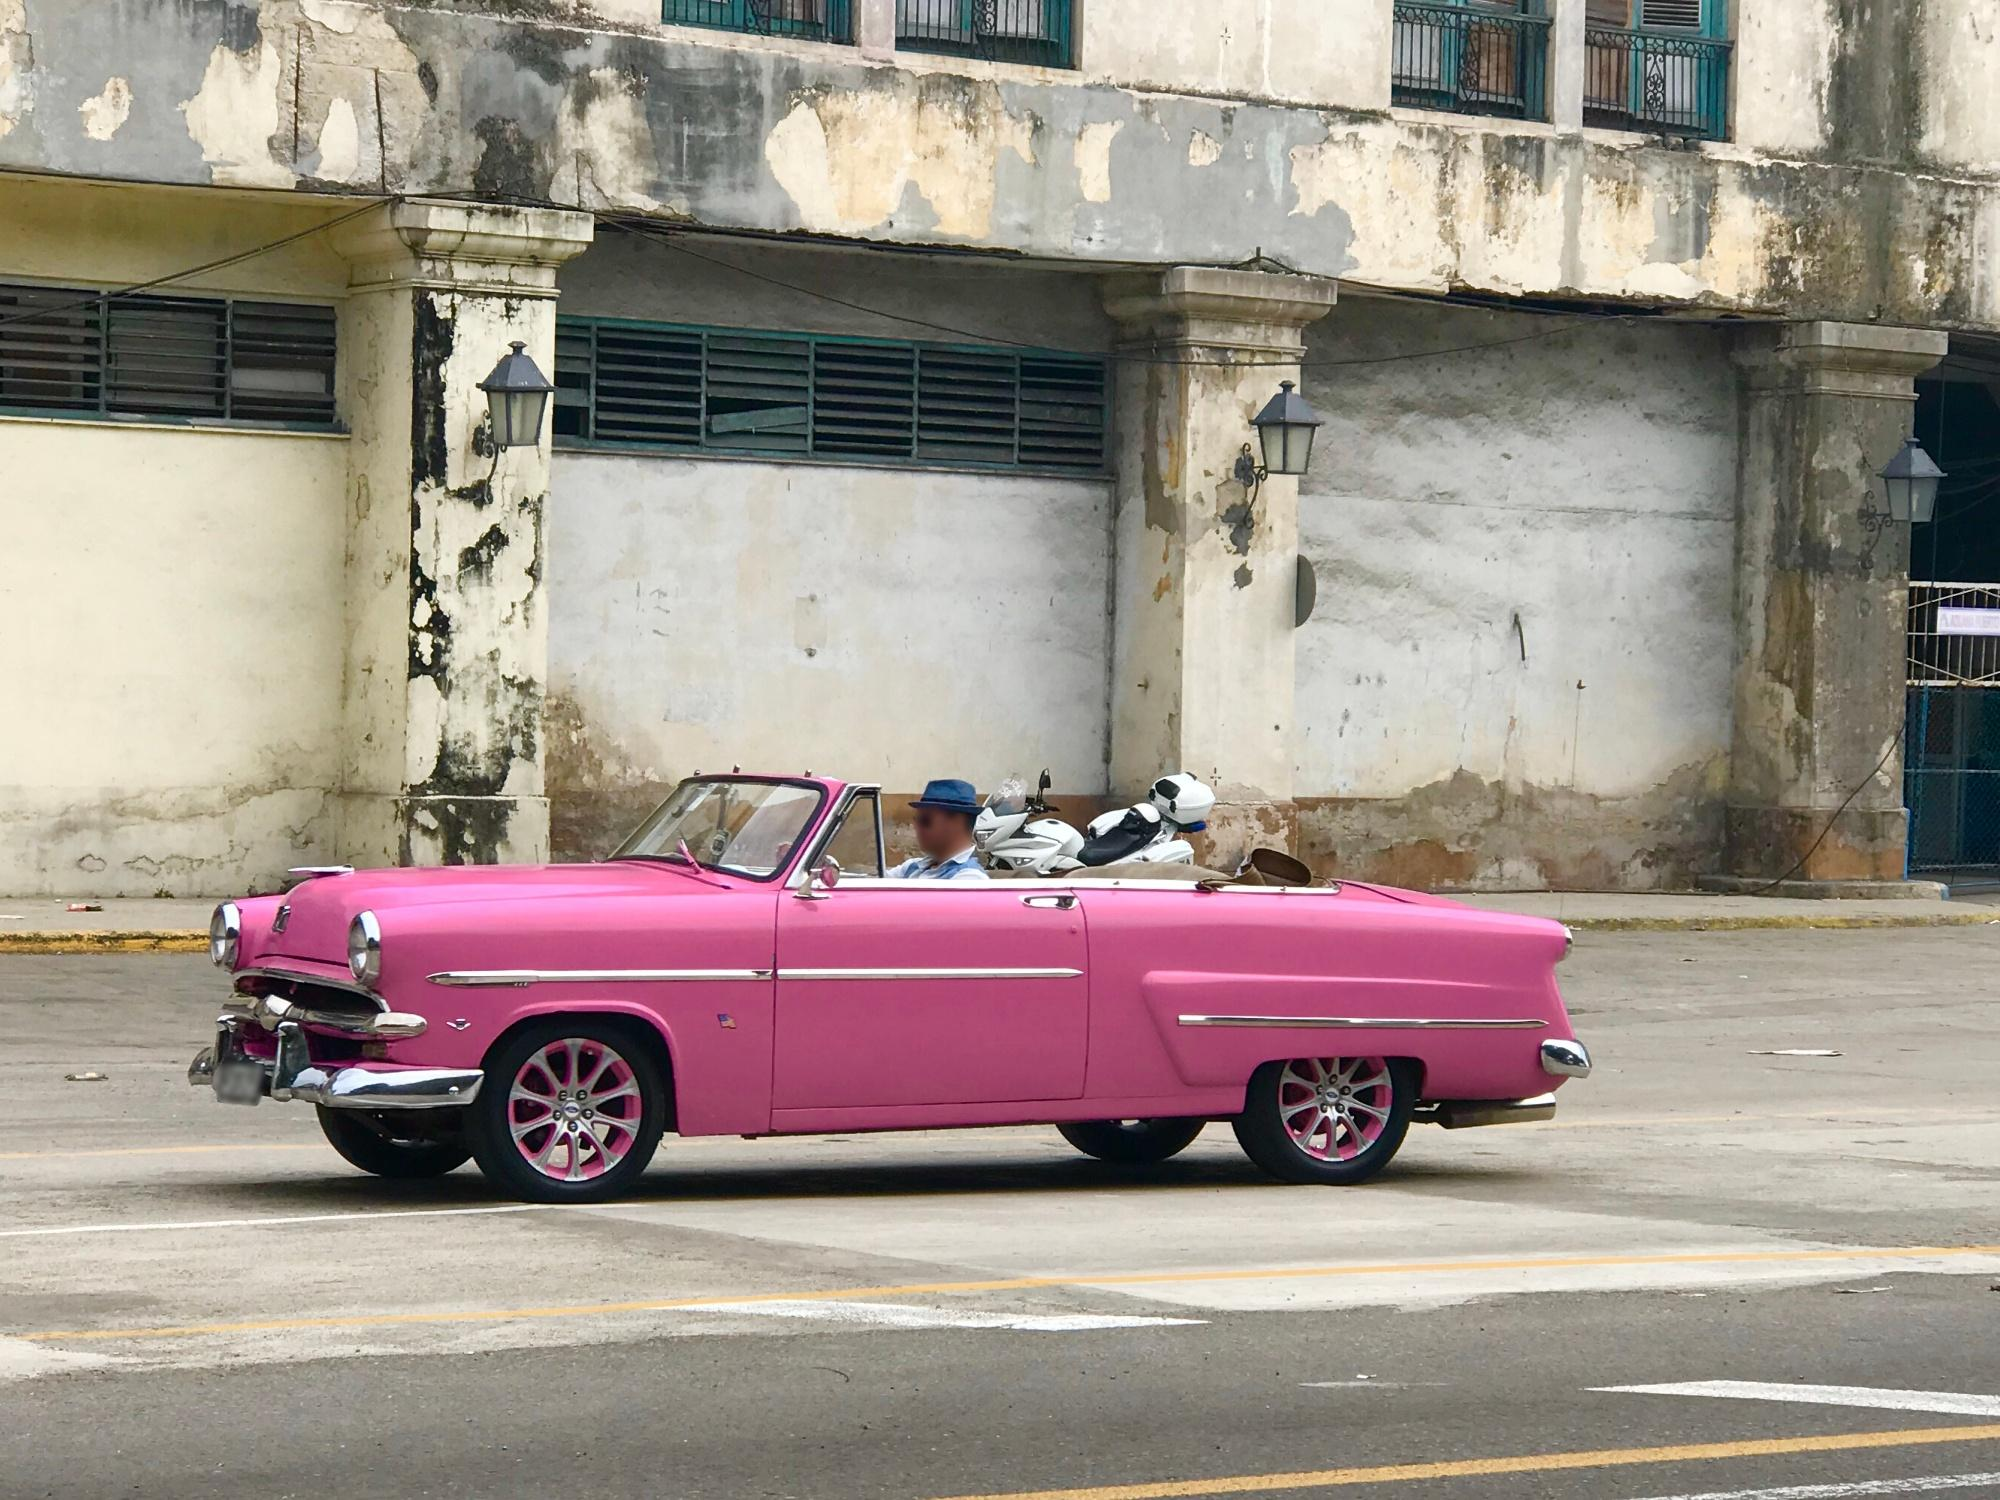What might the presence of this car in such a setting imply about the area's culture or history? The presence of a meticulously maintained vintage car in a deteriorating urban setting might suggest a community that cherishes historical and cultural preservation amidst economic challenges. It could indicate a sense of pride and nostalgia that persists even as the physical environment wears down, signaling an attachment to heritage and identity that transcends the area's current economic state. Could this be part of a trend or specific event in this location? It’s possible that the car is part of a local vintage car enthusiasts’ event or a community initiative to promote tourism and local culture. Events like classic car shows can serve to boost community morale and attract visitors, providing an economic uplift to areas in need of revitalization. 